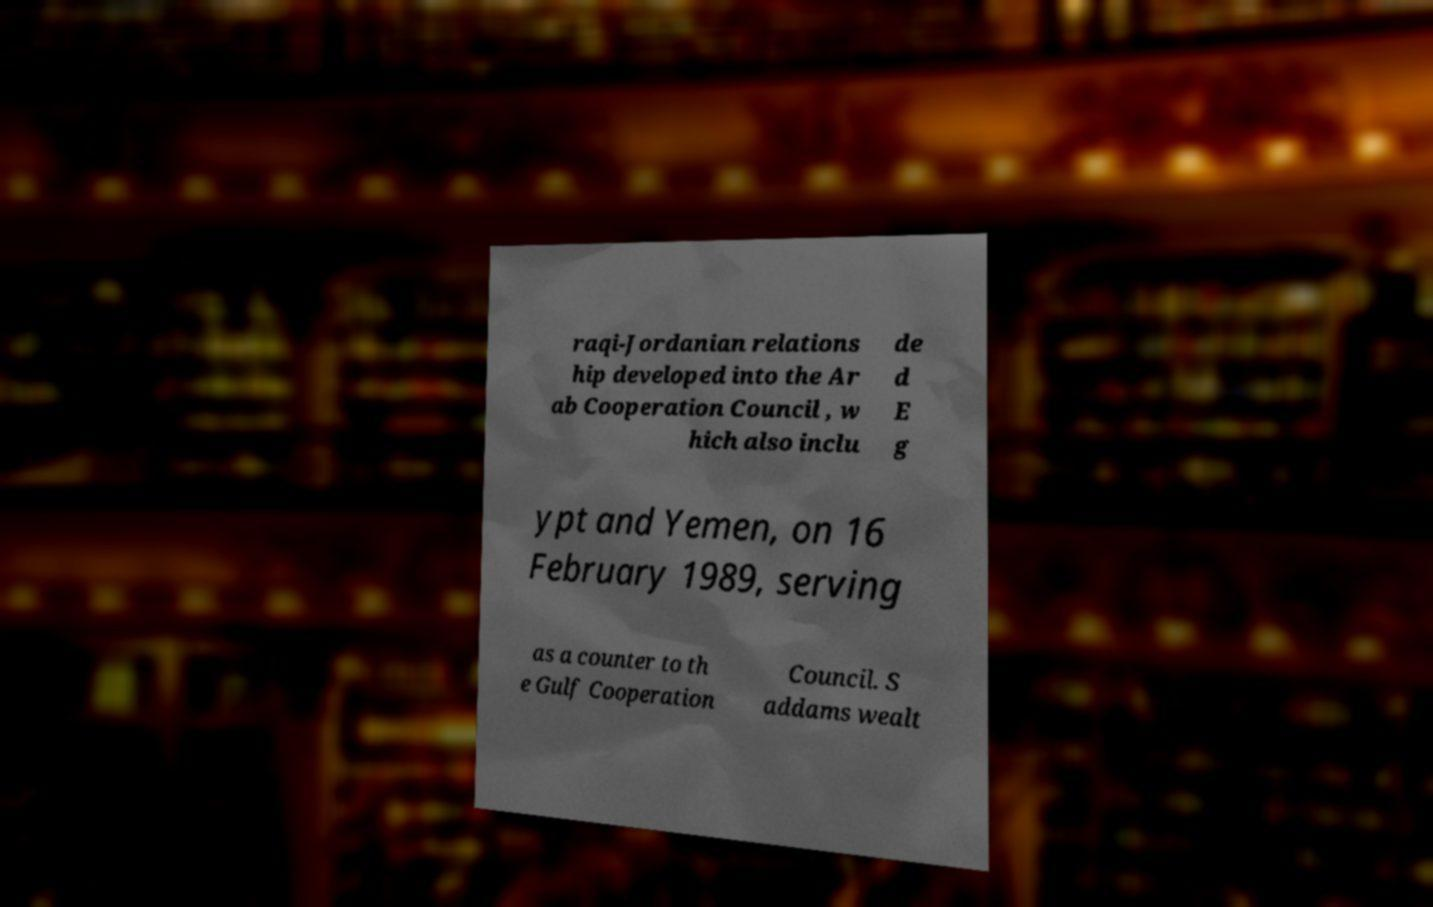For documentation purposes, I need the text within this image transcribed. Could you provide that? raqi-Jordanian relations hip developed into the Ar ab Cooperation Council , w hich also inclu de d E g ypt and Yemen, on 16 February 1989, serving as a counter to th e Gulf Cooperation Council. S addams wealt 